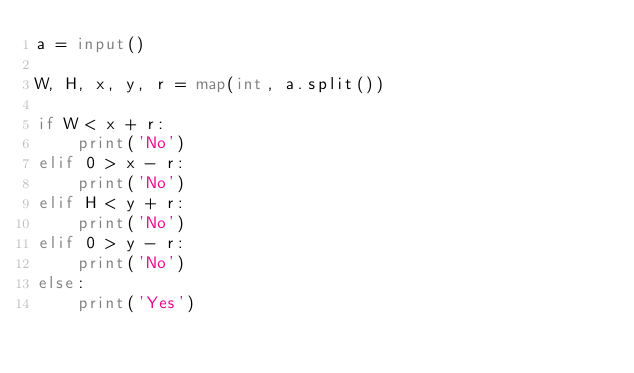<code> <loc_0><loc_0><loc_500><loc_500><_Python_>a = input()

W, H, x, y, r = map(int, a.split())

if W < x + r:
    print('No')
elif 0 > x - r:
    print('No')
elif H < y + r:
    print('No')
elif 0 > y - r:
    print('No')
else:
    print('Yes')
</code> 